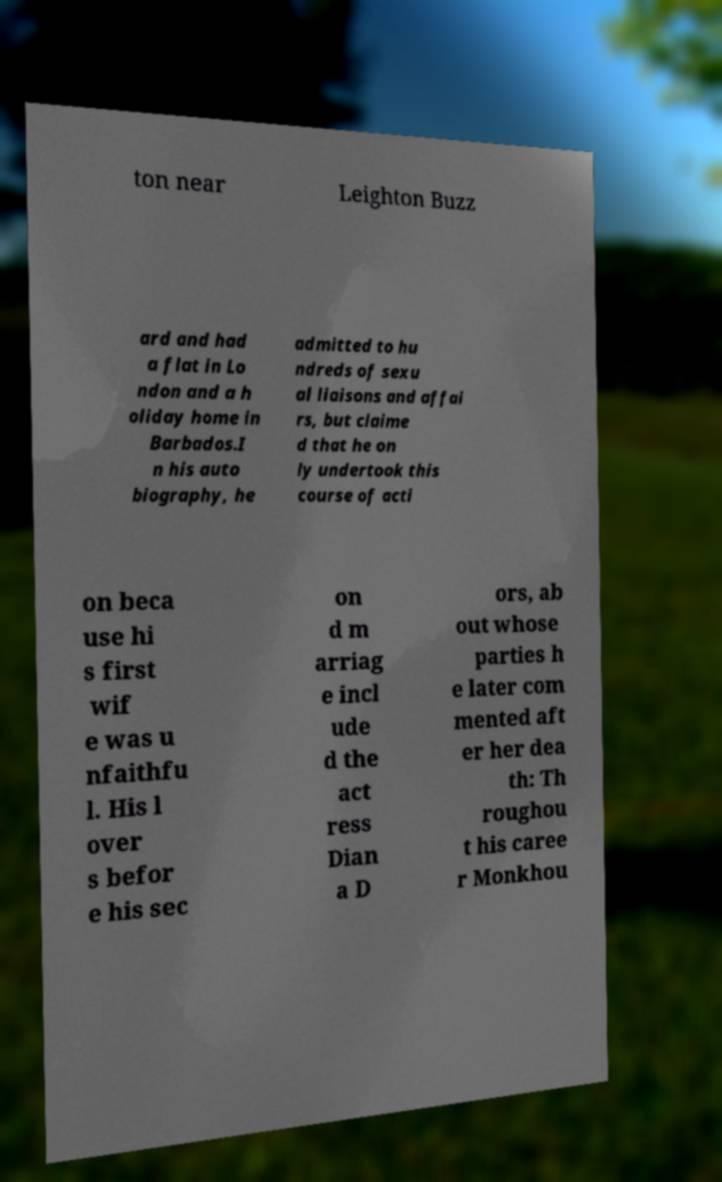I need the written content from this picture converted into text. Can you do that? ton near Leighton Buzz ard and had a flat in Lo ndon and a h oliday home in Barbados.I n his auto biography, he admitted to hu ndreds of sexu al liaisons and affai rs, but claime d that he on ly undertook this course of acti on beca use hi s first wif e was u nfaithfu l. His l over s befor e his sec on d m arriag e incl ude d the act ress Dian a D ors, ab out whose parties h e later com mented aft er her dea th: Th roughou t his caree r Monkhou 